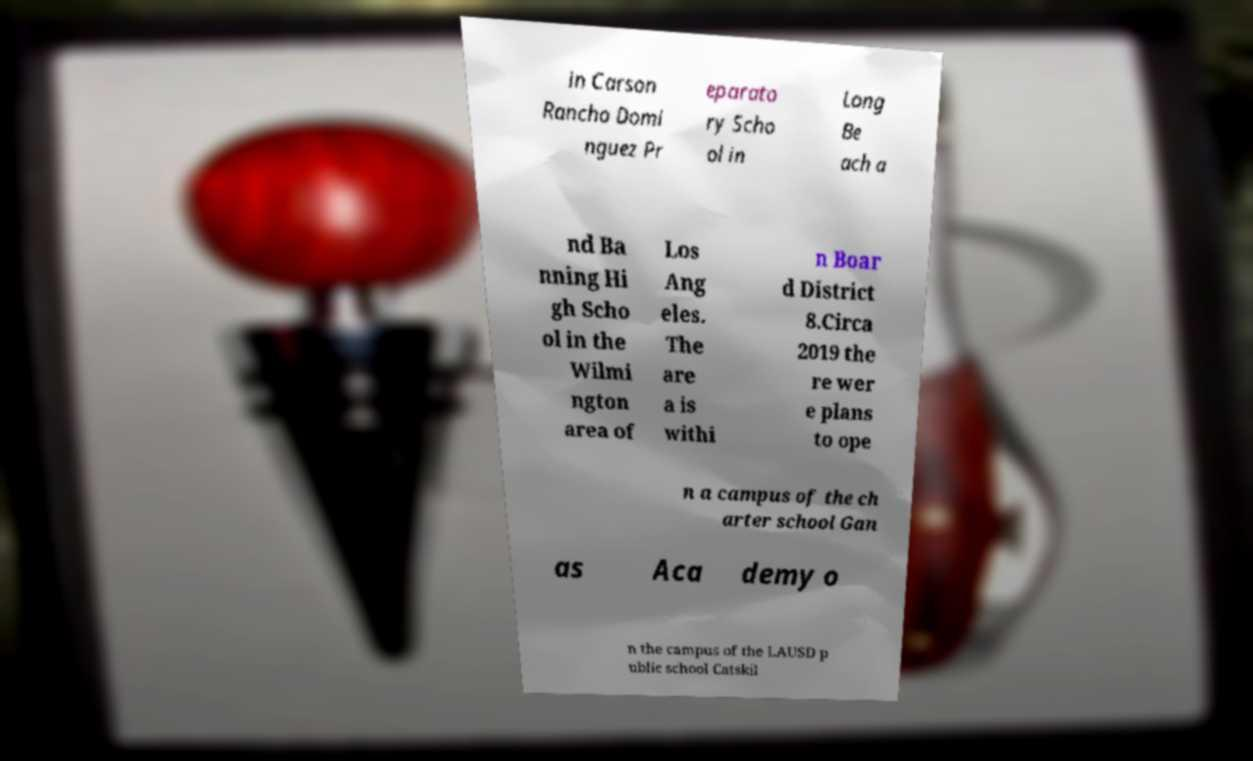Can you accurately transcribe the text from the provided image for me? in Carson Rancho Domi nguez Pr eparato ry Scho ol in Long Be ach a nd Ba nning Hi gh Scho ol in the Wilmi ngton area of Los Ang eles. The are a is withi n Boar d District 8.Circa 2019 the re wer e plans to ope n a campus of the ch arter school Gan as Aca demy o n the campus of the LAUSD p ublic school Catskil 